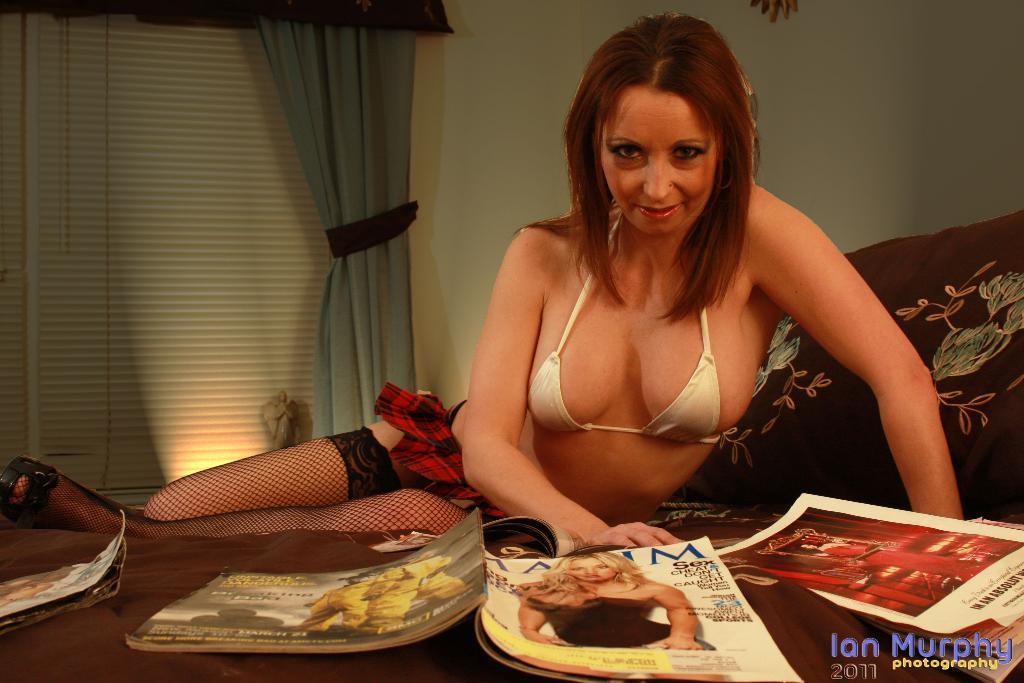Can you describe this image briefly? In this image I can see the person. In front I can see few magazines on the brown color surface. Back I can see the wall, window, curtain and light. 